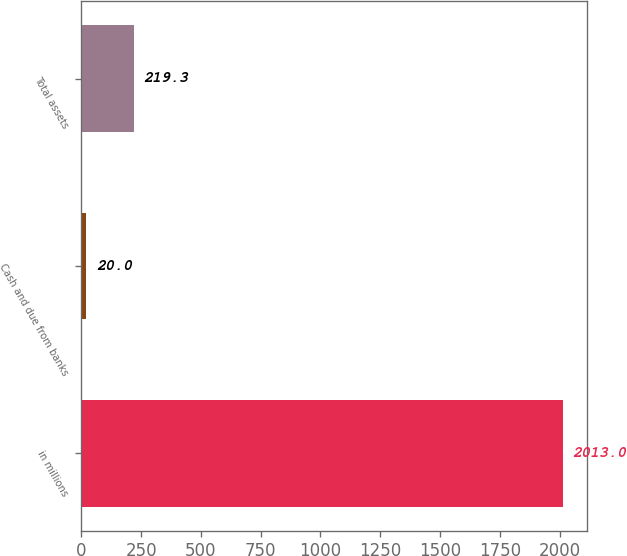Convert chart to OTSL. <chart><loc_0><loc_0><loc_500><loc_500><bar_chart><fcel>in millions<fcel>Cash and due from banks<fcel>Total assets<nl><fcel>2013<fcel>20<fcel>219.3<nl></chart> 